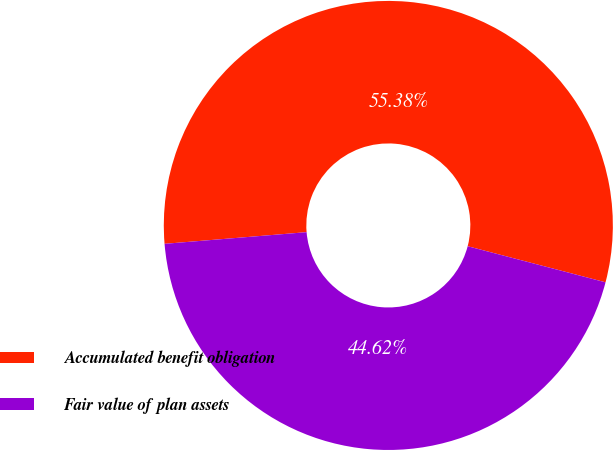Convert chart. <chart><loc_0><loc_0><loc_500><loc_500><pie_chart><fcel>Accumulated benefit obligation<fcel>Fair value of plan assets<nl><fcel>55.38%<fcel>44.62%<nl></chart> 